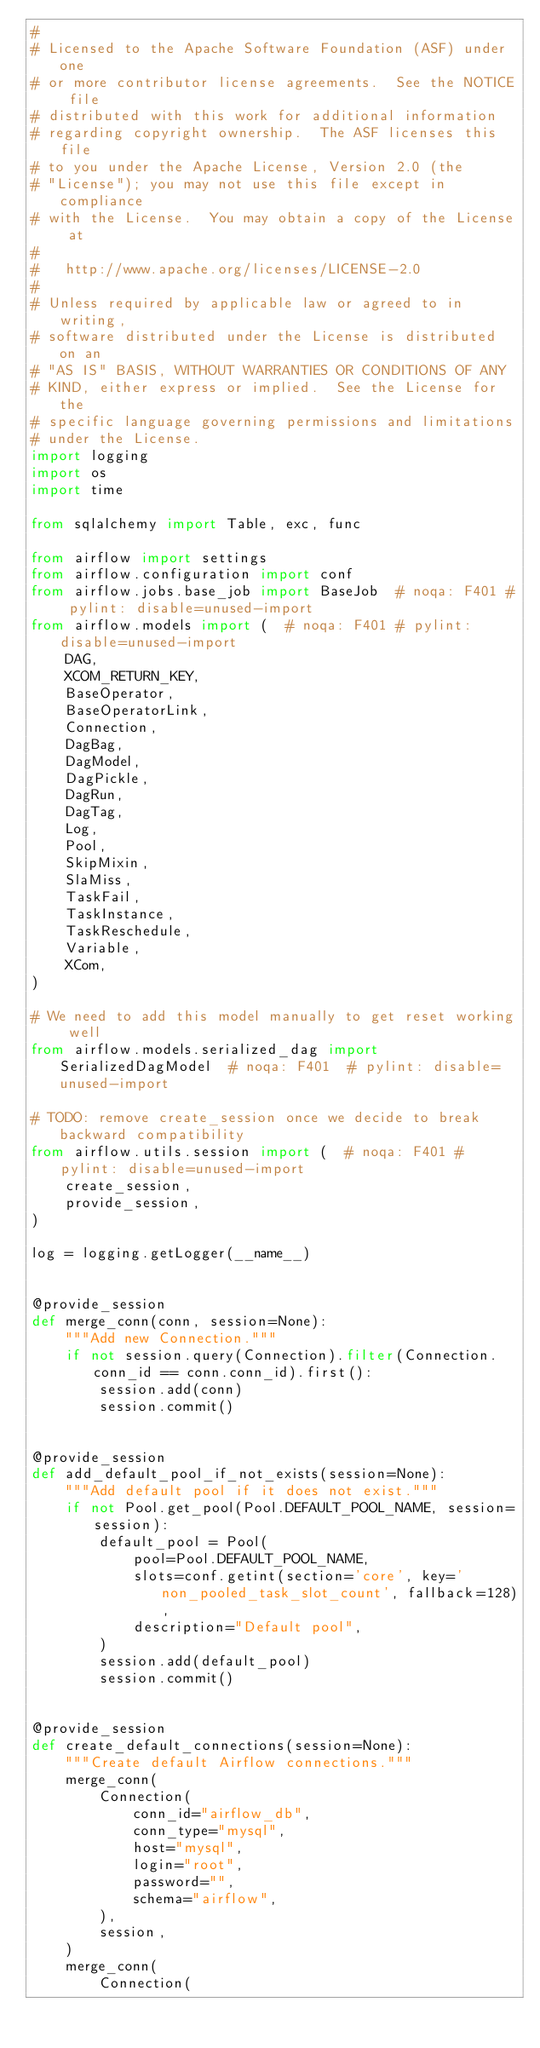<code> <loc_0><loc_0><loc_500><loc_500><_Python_>#
# Licensed to the Apache Software Foundation (ASF) under one
# or more contributor license agreements.  See the NOTICE file
# distributed with this work for additional information
# regarding copyright ownership.  The ASF licenses this file
# to you under the Apache License, Version 2.0 (the
# "License"); you may not use this file except in compliance
# with the License.  You may obtain a copy of the License at
#
#   http://www.apache.org/licenses/LICENSE-2.0
#
# Unless required by applicable law or agreed to in writing,
# software distributed under the License is distributed on an
# "AS IS" BASIS, WITHOUT WARRANTIES OR CONDITIONS OF ANY
# KIND, either express or implied.  See the License for the
# specific language governing permissions and limitations
# under the License.
import logging
import os
import time

from sqlalchemy import Table, exc, func

from airflow import settings
from airflow.configuration import conf
from airflow.jobs.base_job import BaseJob  # noqa: F401 # pylint: disable=unused-import
from airflow.models import (  # noqa: F401 # pylint: disable=unused-import
    DAG,
    XCOM_RETURN_KEY,
    BaseOperator,
    BaseOperatorLink,
    Connection,
    DagBag,
    DagModel,
    DagPickle,
    DagRun,
    DagTag,
    Log,
    Pool,
    SkipMixin,
    SlaMiss,
    TaskFail,
    TaskInstance,
    TaskReschedule,
    Variable,
    XCom,
)

# We need to add this model manually to get reset working well
from airflow.models.serialized_dag import SerializedDagModel  # noqa: F401  # pylint: disable=unused-import

# TODO: remove create_session once we decide to break backward compatibility
from airflow.utils.session import (  # noqa: F401 # pylint: disable=unused-import
    create_session,
    provide_session,
)

log = logging.getLogger(__name__)


@provide_session
def merge_conn(conn, session=None):
    """Add new Connection."""
    if not session.query(Connection).filter(Connection.conn_id == conn.conn_id).first():
        session.add(conn)
        session.commit()


@provide_session
def add_default_pool_if_not_exists(session=None):
    """Add default pool if it does not exist."""
    if not Pool.get_pool(Pool.DEFAULT_POOL_NAME, session=session):
        default_pool = Pool(
            pool=Pool.DEFAULT_POOL_NAME,
            slots=conf.getint(section='core', key='non_pooled_task_slot_count', fallback=128),
            description="Default pool",
        )
        session.add(default_pool)
        session.commit()


@provide_session
def create_default_connections(session=None):
    """Create default Airflow connections."""
    merge_conn(
        Connection(
            conn_id="airflow_db",
            conn_type="mysql",
            host="mysql",
            login="root",
            password="",
            schema="airflow",
        ),
        session,
    )
    merge_conn(
        Connection(</code> 